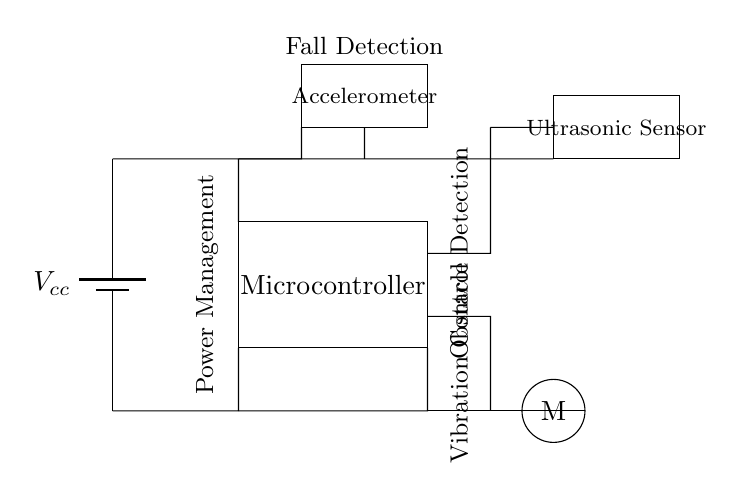What is the purpose of the ultrasonic sensor? The ultrasonic sensor is used for obstacle detection by measuring the distance to nearby objects, helping the user navigate safely.
Answer: obstacle detection How many main components are there in this circuit? The circuit has four main components: the microcontroller, ultrasonic sensor, accelerometer, and vibration motor.
Answer: four What is connected to the vibration motor? The vibration motor is connected to the microcontroller, allowing it to provide feedback when obstacles are detected or when a fall is detected.
Answer: microcontroller What does the accelerometer detect? The accelerometer detects changes in acceleration, which can indicate falls or unstable motion by monitoring the cane's position.
Answer: falls Which component provides power to the circuit? The component providing power to the circuit is the battery, labeled as Vcc, which supplies the required voltage for operation.
Answer: battery What does the label 'Power Management' refer to in the circuit? The label 'Power Management' indicates the part of the circuit that provides and manages the voltage supply to different components, ensuring they operate effectively.
Answer: voltage supply How does the microcontroller contribute to fall detection? The microcontroller processes data from the accelerometer to determine if a fall has occurred by analyzing patterns of movement and triggering the motor for feedback.
Answer: processing data 